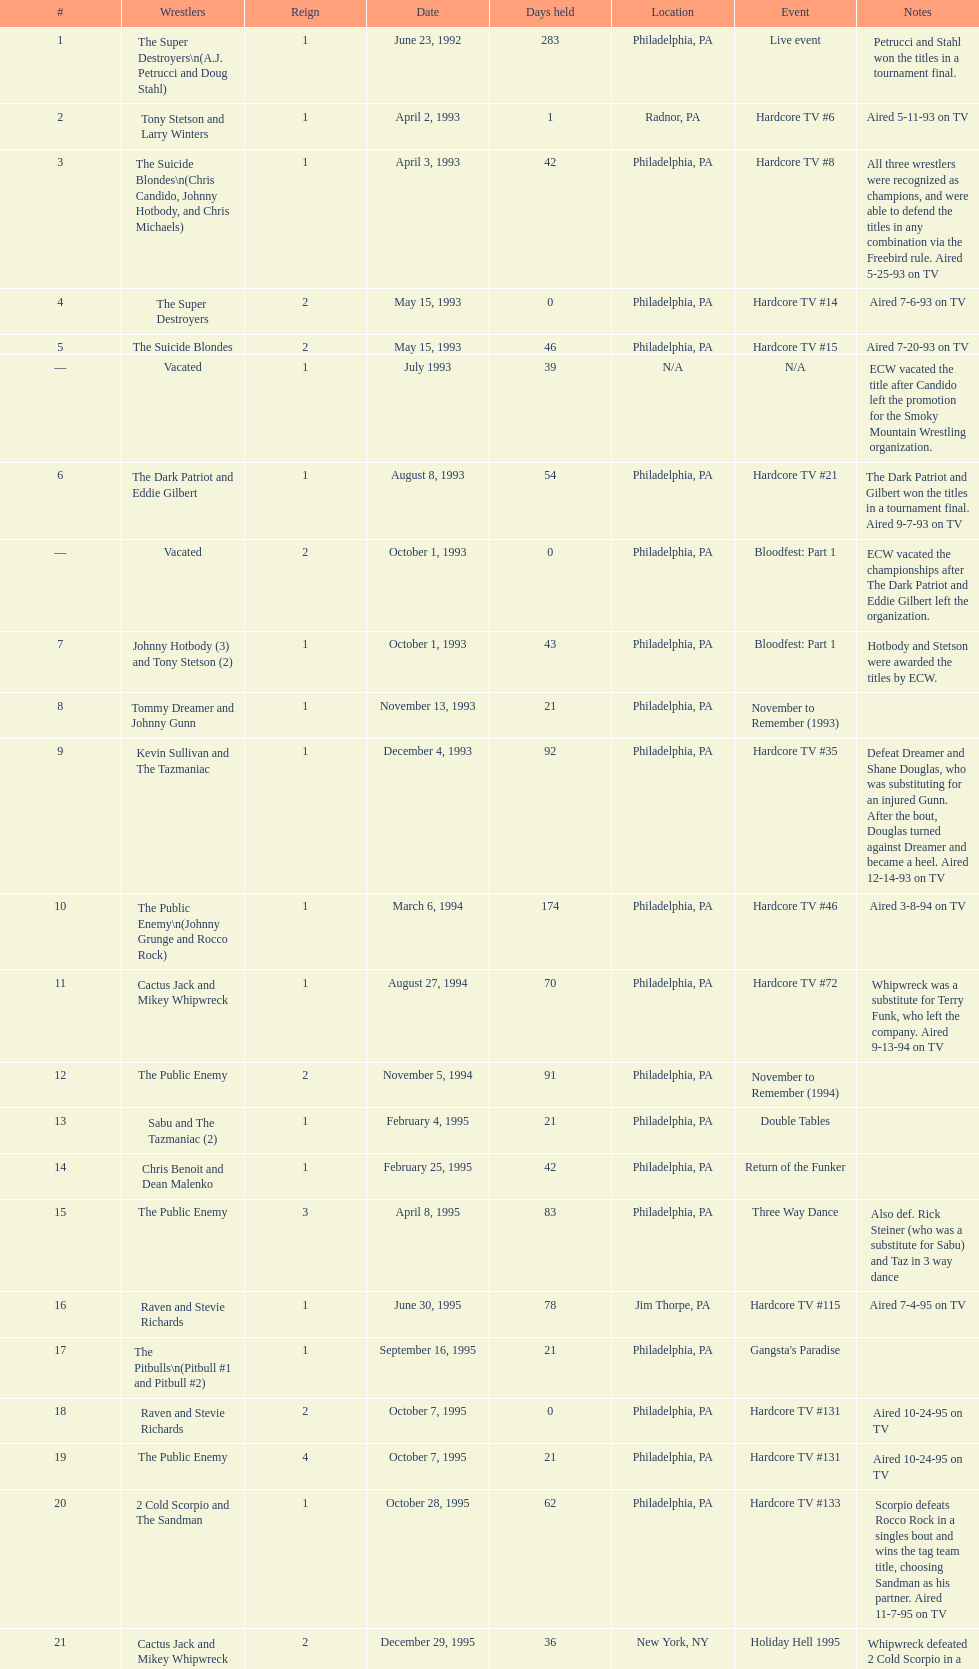What incident happens prior to the 14th episode of hardcore tv? Hardcore TV #8. 